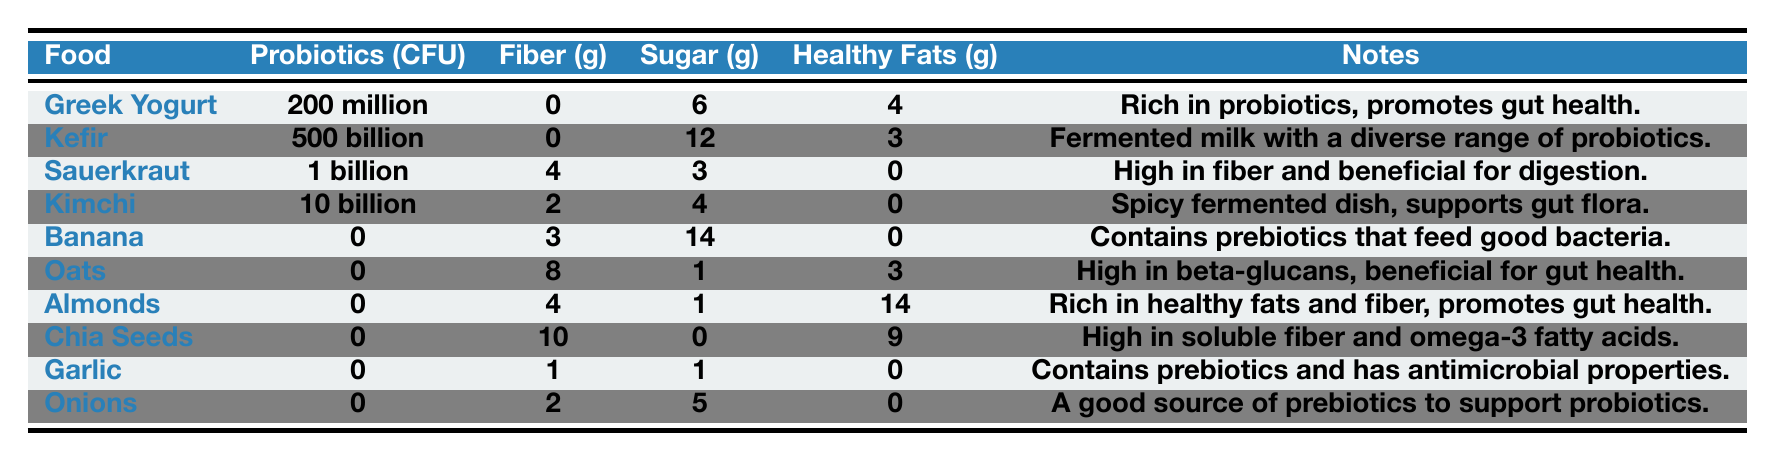What food has the highest probiotics per serving? Kefir contains 500 billion CFU of probiotics, which is the highest amount listed in the table. Other foods, such as Greek yogurt, have significantly lower amounts.
Answer: Kefir Which food has the highest fiber content? Chia seeds have the highest fiber content at 10 g per serving, compared to other foods which have lower fiber levels.
Answer: Chia Seeds What is the total sugar content of Greek Yogurt and Kimchi combined? The sugar content for Greek yogurt is 6 g and for Kimchi is 4 g. Adding these together gives a total of 10 g (6 + 4).
Answer: 10 g Is there any food listed that has both probiotics and fiber? Yes, Sauerkraut has 1 billion CFU of probiotics and 4 g of fiber, indicating it contains both beneficial elements.
Answer: Yes Which food has no probiotics but the highest amount of healthy fats? Almonds have no probiotics (0 CFU) but contain the highest amount of healthy fats at 14 g per serving.
Answer: Almonds What is the average fiber content of all foods listed in the table? The fiber contents are: 0, 0, 4, 2, 3, 8, 4, 10, 1, and 2 g. Adding these gives a total of 30 g. There are 10 foods, so the average fiber content is 30/10 = 3 g.
Answer: 3 g Is it true that all the foods listed have zero probiotics? No, that is false because both Kefir and Greek Yogurt have probiotics, with amounts of 500 billion CFU and 200 million CFU, respectively.
Answer: No What are the only foods that provide prebiotics? The foods that provide prebiotics are Banana, Garlic, and Onions, as indicated in their notes about feeding good bacteria or supporting probiotics.
Answer: Banana, Garlic, Onions How much sugar do Oats and Chia Seeds contain together? Oats have 1 g of sugar, and Chia Seeds have 0 g. Adding these provides a total sugar content of 1 g (1 + 0).
Answer: 1 g What is the difference in probiotics per serving between Greek Yogurt and Sauerkraut? Greek Yogurt has 200 million CFU and Sauerkraut has 1 billion CFU. Converting 1 billion CFU to million gives 1000 million CFU, so the difference is 1000 - 200 = 800 million CFU.
Answer: 800 million CFU 